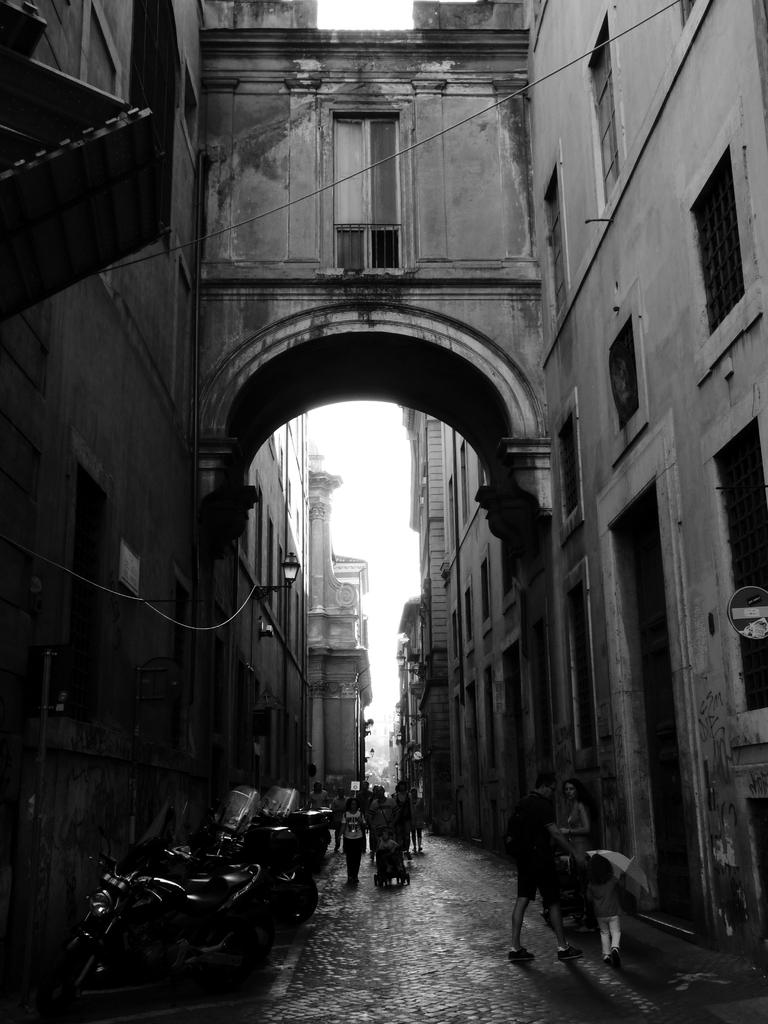What type of structures are present in the image? There are buildings with windows in the image. Can you describe a specific architectural feature in the image? Yes, there is an arch in the image. What is the primary mode of transportation visible in the image? There are vehicles in the image. Are there any human figures present in the image? Yes, there are people in the image. What can be seen in the background of the image? The sky is visible in the background of the image. What type of manager is overseeing the children playing in the image? There are no children or managers present in the image. How many times do the people in the image kick the ball? There is no ball present in the image, so it is not possible to determine how many times it is kicked. 